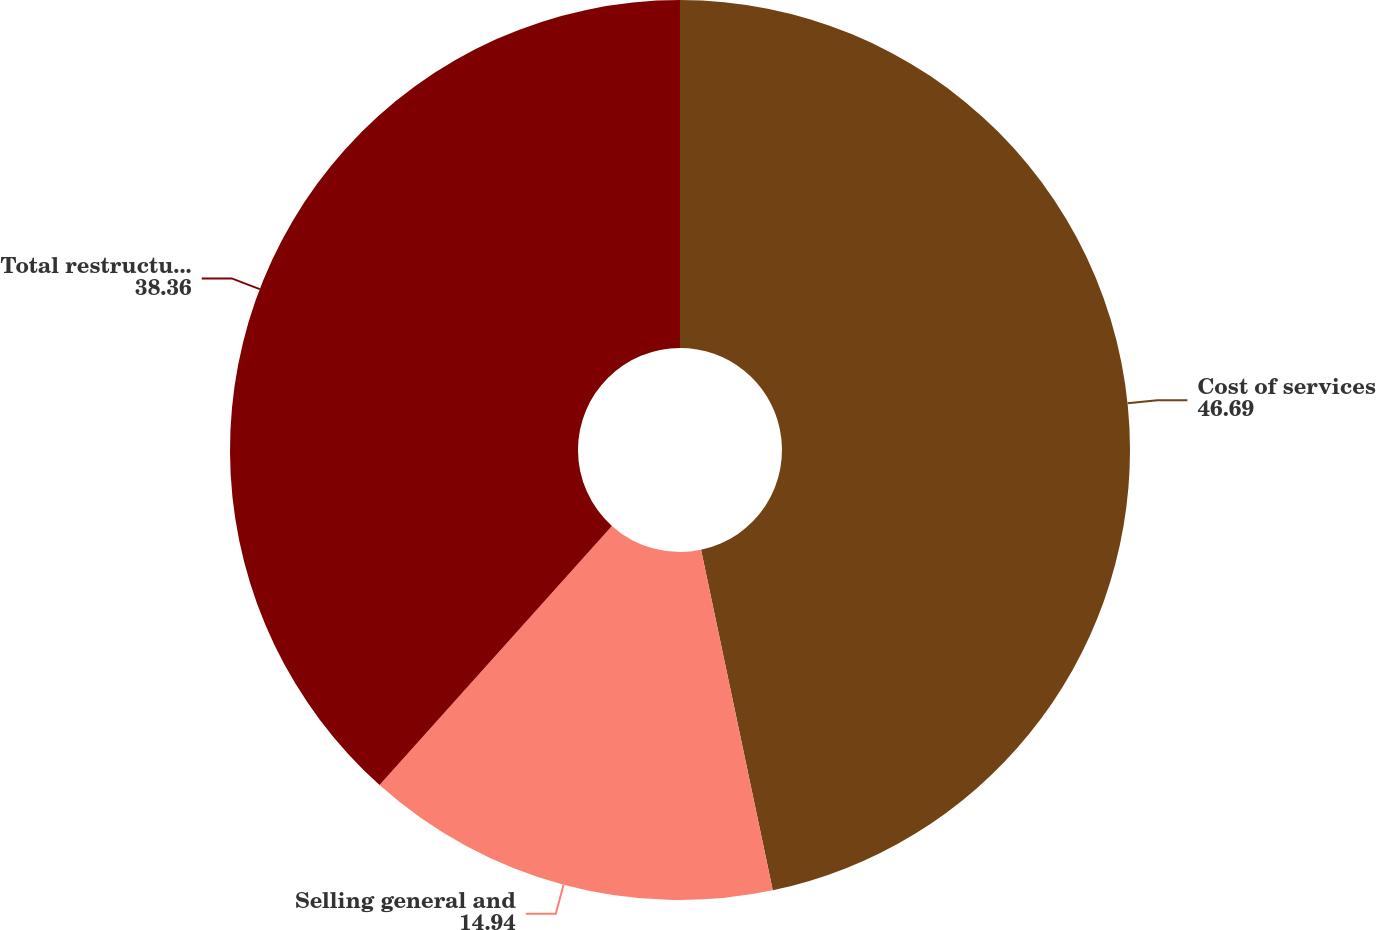<chart> <loc_0><loc_0><loc_500><loc_500><pie_chart><fcel>Cost of services<fcel>Selling general and<fcel>Total restructuring and<nl><fcel>46.69%<fcel>14.94%<fcel>38.36%<nl></chart> 